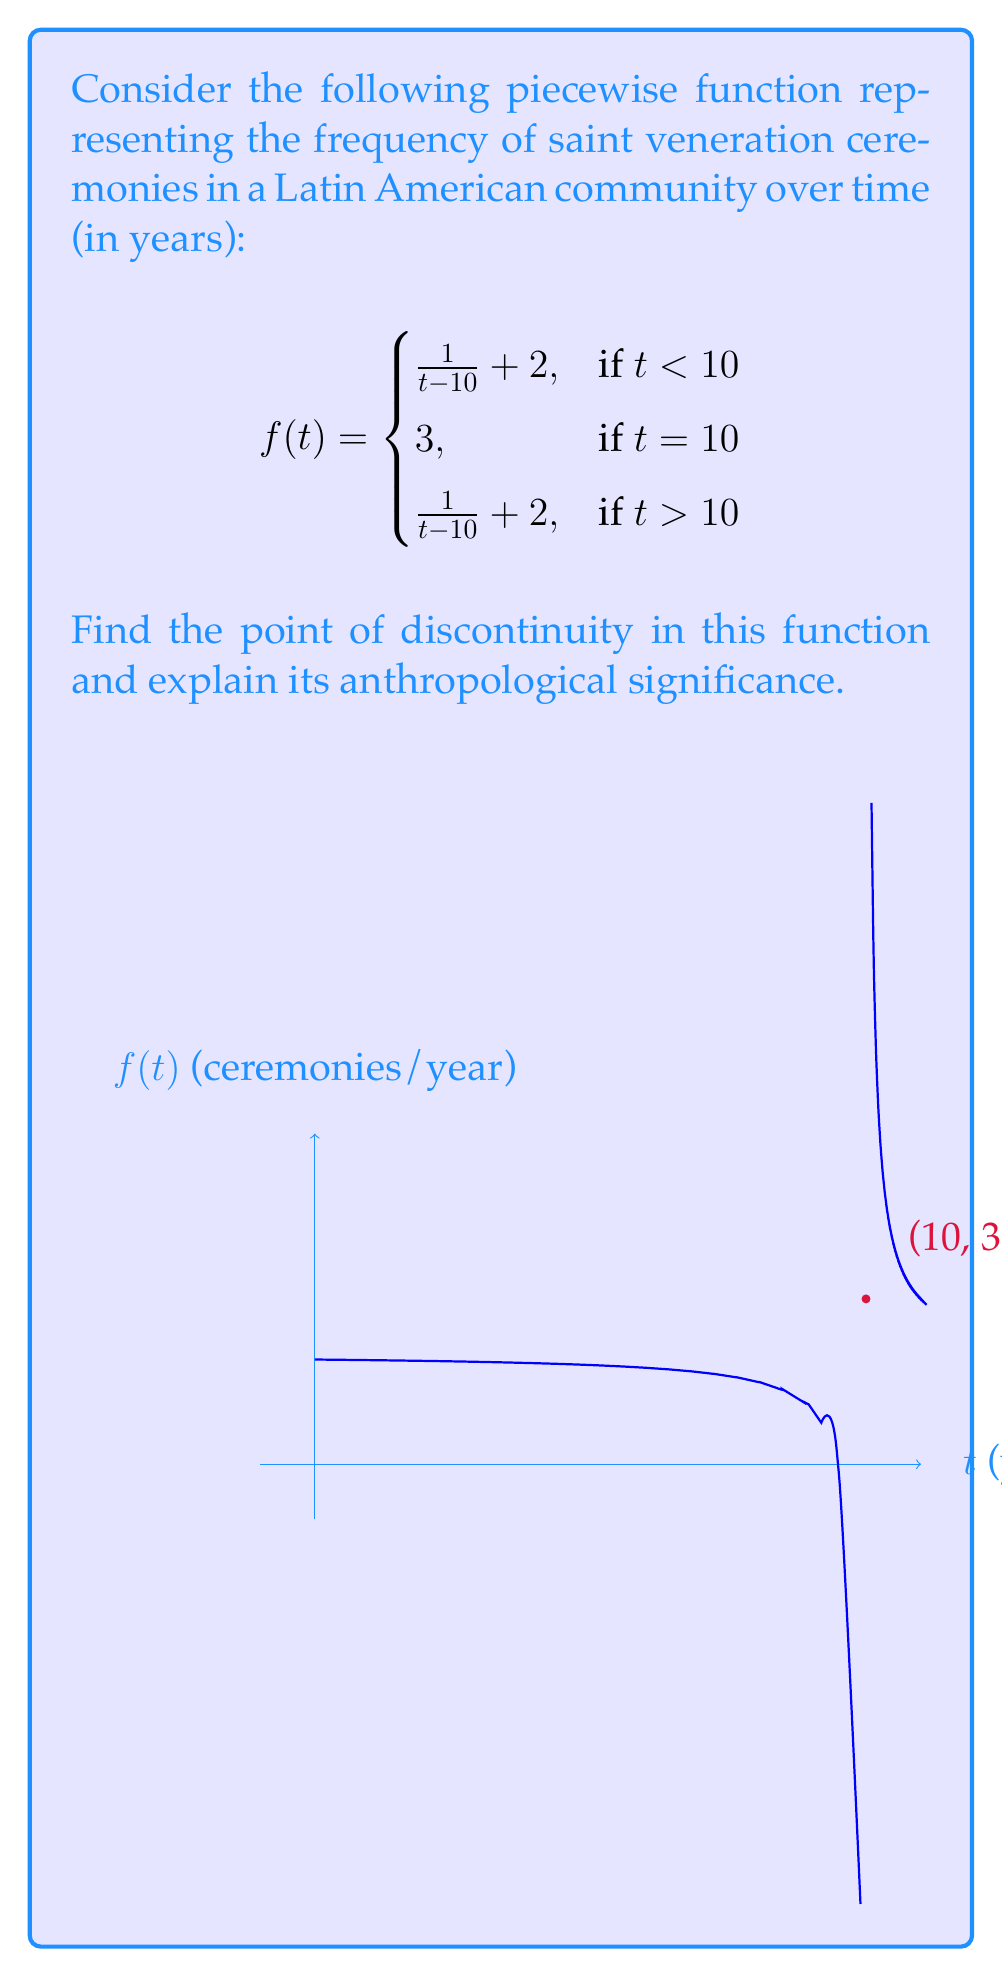Help me with this question. To find the point of discontinuity, we need to analyze the function at and around $t = 10$:

1) For $t < 10$: $\lim_{t \to 10^-} f(t) = \lim_{t \to 10^-} (\frac{1}{t-10} + 2) = +\infty$

2) For $t > 10$: $\lim_{t \to 10^+} f(t) = \lim_{t \to 10^+} (\frac{1}{t-10} + 2) = +\infty$

3) At $t = 10$: $f(10) = 3$

The function is discontinuous at $t = 10$ because:
- The limit as $t$ approaches 10 from both sides is infinity, which doesn't equal $f(10) = 3$.
- The left-hand limit doesn't equal the right-hand limit (although both are infinity).

Anthropological significance:
This discontinuity at $t = 10$ could represent a significant event or change in the community's religious practices. The spike in ceremony frequency as $t$ approaches 10 from both sides might indicate an intensification of religious activity leading up to a pivotal moment (e.g., a major religious festival or the canonization of a new saint). The sudden drop to a finite value at exactly $t = 10$ could symbolize a temporary pause or change in practice during the event itself, before returning to the intensified state immediately after.
Answer: $t = 10$ 